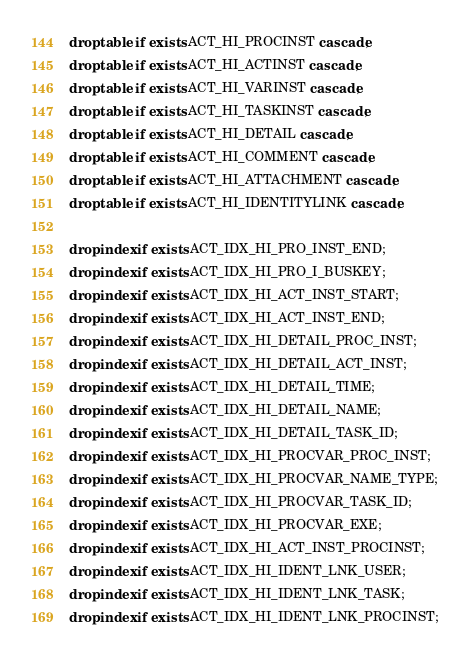<code> <loc_0><loc_0><loc_500><loc_500><_SQL_>drop table if exists ACT_HI_PROCINST cascade;
drop table if exists ACT_HI_ACTINST cascade;
drop table if exists ACT_HI_VARINST cascade;
drop table if exists ACT_HI_TASKINST cascade;
drop table if exists ACT_HI_DETAIL cascade;
drop table if exists ACT_HI_COMMENT cascade;
drop table if exists ACT_HI_ATTACHMENT cascade;
drop table if exists ACT_HI_IDENTITYLINK cascade;

drop index if exists ACT_IDX_HI_PRO_INST_END;
drop index if exists ACT_IDX_HI_PRO_I_BUSKEY;
drop index if exists ACT_IDX_HI_ACT_INST_START;
drop index if exists ACT_IDX_HI_ACT_INST_END;
drop index if exists ACT_IDX_HI_DETAIL_PROC_INST;
drop index if exists ACT_IDX_HI_DETAIL_ACT_INST;
drop index if exists ACT_IDX_HI_DETAIL_TIME;
drop index if exists ACT_IDX_HI_DETAIL_NAME;
drop index if exists ACT_IDX_HI_DETAIL_TASK_ID;
drop index if exists ACT_IDX_HI_PROCVAR_PROC_INST;
drop index if exists ACT_IDX_HI_PROCVAR_NAME_TYPE;
drop index if exists ACT_IDX_HI_PROCVAR_TASK_ID;
drop index if exists ACT_IDX_HI_PROCVAR_EXE;
drop index if exists ACT_IDX_HI_ACT_INST_PROCINST;
drop index if exists ACT_IDX_HI_IDENT_LNK_USER;
drop index if exists ACT_IDX_HI_IDENT_LNK_TASK;
drop index if exists ACT_IDX_HI_IDENT_LNK_PROCINST;
</code> 